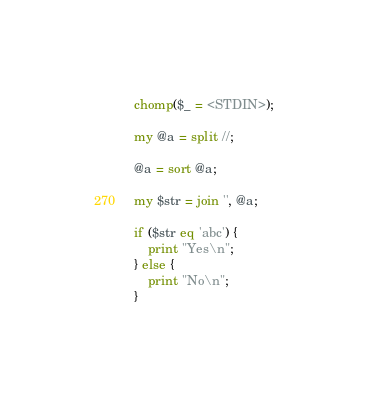<code> <loc_0><loc_0><loc_500><loc_500><_Perl_>chomp($_ = <STDIN>);

my @a = split //;

@a = sort @a;

my $str = join '', @a;

if ($str eq 'abc') {
    print "Yes\n";
} else {
    print "No\n";
}
</code> 